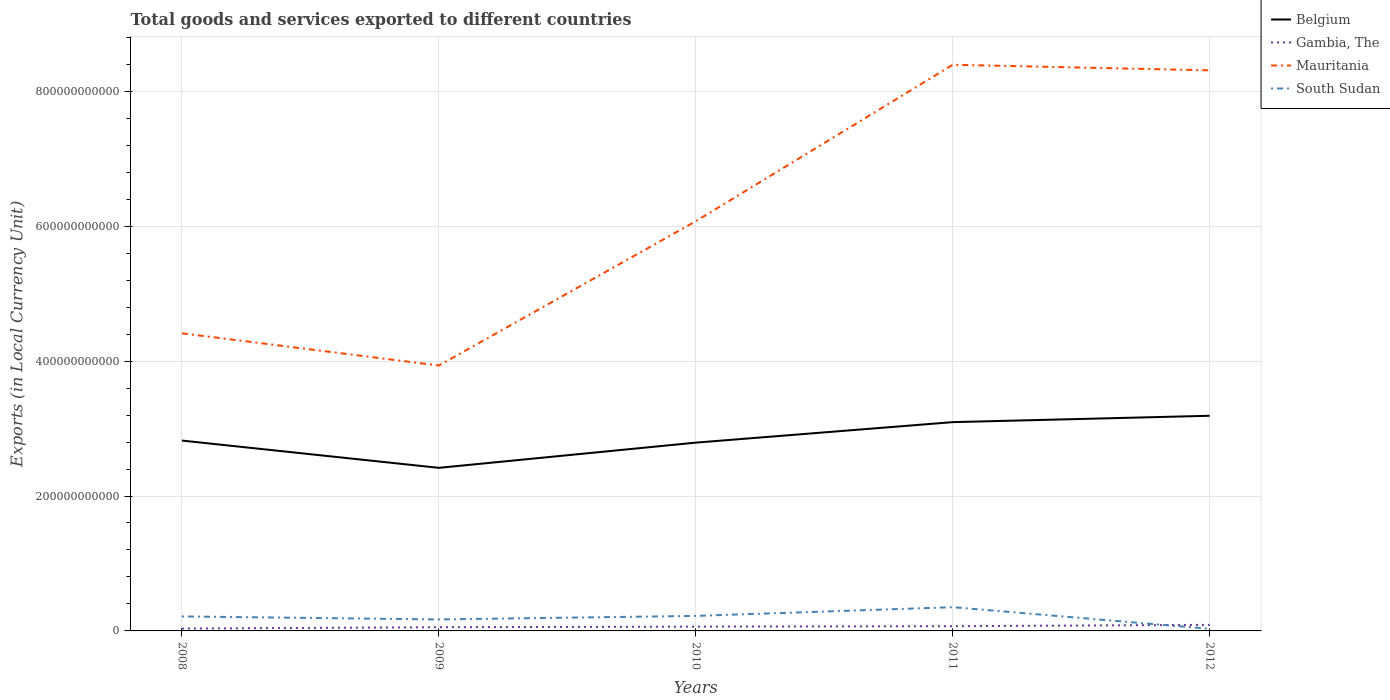How many different coloured lines are there?
Keep it short and to the point. 4. Does the line corresponding to Mauritania intersect with the line corresponding to Belgium?
Provide a short and direct response. No. Is the number of lines equal to the number of legend labels?
Provide a short and direct response. Yes. Across all years, what is the maximum Amount of goods and services exports in Belgium?
Offer a terse response. 2.42e+11. In which year was the Amount of goods and services exports in Belgium maximum?
Your answer should be very brief. 2009. What is the total Amount of goods and services exports in Belgium in the graph?
Your response must be concise. -3.74e+1. What is the difference between the highest and the second highest Amount of goods and services exports in Mauritania?
Provide a succinct answer. 4.46e+11. How many lines are there?
Your answer should be compact. 4. What is the difference between two consecutive major ticks on the Y-axis?
Give a very brief answer. 2.00e+11. Are the values on the major ticks of Y-axis written in scientific E-notation?
Keep it short and to the point. No. How many legend labels are there?
Keep it short and to the point. 4. What is the title of the graph?
Ensure brevity in your answer.  Total goods and services exported to different countries. Does "Solomon Islands" appear as one of the legend labels in the graph?
Keep it short and to the point. No. What is the label or title of the X-axis?
Provide a succinct answer. Years. What is the label or title of the Y-axis?
Your answer should be very brief. Exports (in Local Currency Unit). What is the Exports (in Local Currency Unit) in Belgium in 2008?
Keep it short and to the point. 2.82e+11. What is the Exports (in Local Currency Unit) in Gambia, The in 2008?
Your response must be concise. 3.47e+09. What is the Exports (in Local Currency Unit) in Mauritania in 2008?
Ensure brevity in your answer.  4.41e+11. What is the Exports (in Local Currency Unit) of South Sudan in 2008?
Provide a succinct answer. 2.15e+1. What is the Exports (in Local Currency Unit) in Belgium in 2009?
Your response must be concise. 2.42e+11. What is the Exports (in Local Currency Unit) of Gambia, The in 2009?
Ensure brevity in your answer.  5.50e+09. What is the Exports (in Local Currency Unit) of Mauritania in 2009?
Keep it short and to the point. 3.93e+11. What is the Exports (in Local Currency Unit) in South Sudan in 2009?
Offer a terse response. 1.70e+1. What is the Exports (in Local Currency Unit) of Belgium in 2010?
Provide a short and direct response. 2.79e+11. What is the Exports (in Local Currency Unit) in Gambia, The in 2010?
Your answer should be very brief. 6.34e+09. What is the Exports (in Local Currency Unit) of Mauritania in 2010?
Your response must be concise. 6.07e+11. What is the Exports (in Local Currency Unit) in South Sudan in 2010?
Offer a very short reply. 2.23e+1. What is the Exports (in Local Currency Unit) of Belgium in 2011?
Your response must be concise. 3.09e+11. What is the Exports (in Local Currency Unit) in Gambia, The in 2011?
Make the answer very short. 7.00e+09. What is the Exports (in Local Currency Unit) in Mauritania in 2011?
Give a very brief answer. 8.39e+11. What is the Exports (in Local Currency Unit) in South Sudan in 2011?
Offer a very short reply. 3.52e+1. What is the Exports (in Local Currency Unit) in Belgium in 2012?
Give a very brief answer. 3.19e+11. What is the Exports (in Local Currency Unit) of Gambia, The in 2012?
Offer a very short reply. 9.01e+09. What is the Exports (in Local Currency Unit) of Mauritania in 2012?
Make the answer very short. 8.31e+11. What is the Exports (in Local Currency Unit) in South Sudan in 2012?
Your response must be concise. 3.10e+09. Across all years, what is the maximum Exports (in Local Currency Unit) in Belgium?
Offer a very short reply. 3.19e+11. Across all years, what is the maximum Exports (in Local Currency Unit) in Gambia, The?
Keep it short and to the point. 9.01e+09. Across all years, what is the maximum Exports (in Local Currency Unit) in Mauritania?
Your answer should be compact. 8.39e+11. Across all years, what is the maximum Exports (in Local Currency Unit) in South Sudan?
Offer a terse response. 3.52e+1. Across all years, what is the minimum Exports (in Local Currency Unit) of Belgium?
Your response must be concise. 2.42e+11. Across all years, what is the minimum Exports (in Local Currency Unit) of Gambia, The?
Your response must be concise. 3.47e+09. Across all years, what is the minimum Exports (in Local Currency Unit) of Mauritania?
Offer a terse response. 3.93e+11. Across all years, what is the minimum Exports (in Local Currency Unit) of South Sudan?
Offer a terse response. 3.10e+09. What is the total Exports (in Local Currency Unit) in Belgium in the graph?
Your answer should be compact. 1.43e+12. What is the total Exports (in Local Currency Unit) of Gambia, The in the graph?
Offer a terse response. 3.13e+1. What is the total Exports (in Local Currency Unit) of Mauritania in the graph?
Provide a succinct answer. 3.11e+12. What is the total Exports (in Local Currency Unit) of South Sudan in the graph?
Keep it short and to the point. 9.91e+1. What is the difference between the Exports (in Local Currency Unit) in Belgium in 2008 and that in 2009?
Offer a terse response. 4.04e+1. What is the difference between the Exports (in Local Currency Unit) of Gambia, The in 2008 and that in 2009?
Keep it short and to the point. -2.03e+09. What is the difference between the Exports (in Local Currency Unit) of Mauritania in 2008 and that in 2009?
Give a very brief answer. 4.78e+1. What is the difference between the Exports (in Local Currency Unit) of South Sudan in 2008 and that in 2009?
Give a very brief answer. 4.43e+09. What is the difference between the Exports (in Local Currency Unit) in Belgium in 2008 and that in 2010?
Ensure brevity in your answer.  3.06e+09. What is the difference between the Exports (in Local Currency Unit) of Gambia, The in 2008 and that in 2010?
Give a very brief answer. -2.87e+09. What is the difference between the Exports (in Local Currency Unit) in Mauritania in 2008 and that in 2010?
Make the answer very short. -1.66e+11. What is the difference between the Exports (in Local Currency Unit) of South Sudan in 2008 and that in 2010?
Ensure brevity in your answer.  -7.98e+08. What is the difference between the Exports (in Local Currency Unit) in Belgium in 2008 and that in 2011?
Your response must be concise. -2.73e+1. What is the difference between the Exports (in Local Currency Unit) of Gambia, The in 2008 and that in 2011?
Ensure brevity in your answer.  -3.54e+09. What is the difference between the Exports (in Local Currency Unit) in Mauritania in 2008 and that in 2011?
Provide a short and direct response. -3.98e+11. What is the difference between the Exports (in Local Currency Unit) in South Sudan in 2008 and that in 2011?
Make the answer very short. -1.37e+1. What is the difference between the Exports (in Local Currency Unit) in Belgium in 2008 and that in 2012?
Make the answer very short. -3.68e+1. What is the difference between the Exports (in Local Currency Unit) in Gambia, The in 2008 and that in 2012?
Provide a short and direct response. -5.54e+09. What is the difference between the Exports (in Local Currency Unit) of Mauritania in 2008 and that in 2012?
Ensure brevity in your answer.  -3.90e+11. What is the difference between the Exports (in Local Currency Unit) of South Sudan in 2008 and that in 2012?
Provide a succinct answer. 1.84e+1. What is the difference between the Exports (in Local Currency Unit) in Belgium in 2009 and that in 2010?
Your answer should be compact. -3.74e+1. What is the difference between the Exports (in Local Currency Unit) in Gambia, The in 2009 and that in 2010?
Keep it short and to the point. -8.44e+08. What is the difference between the Exports (in Local Currency Unit) in Mauritania in 2009 and that in 2010?
Give a very brief answer. -2.14e+11. What is the difference between the Exports (in Local Currency Unit) in South Sudan in 2009 and that in 2010?
Provide a succinct answer. -5.23e+09. What is the difference between the Exports (in Local Currency Unit) in Belgium in 2009 and that in 2011?
Ensure brevity in your answer.  -6.77e+1. What is the difference between the Exports (in Local Currency Unit) in Gambia, The in 2009 and that in 2011?
Your answer should be compact. -1.50e+09. What is the difference between the Exports (in Local Currency Unit) of Mauritania in 2009 and that in 2011?
Provide a short and direct response. -4.46e+11. What is the difference between the Exports (in Local Currency Unit) in South Sudan in 2009 and that in 2011?
Keep it short and to the point. -1.82e+1. What is the difference between the Exports (in Local Currency Unit) of Belgium in 2009 and that in 2012?
Offer a very short reply. -7.72e+1. What is the difference between the Exports (in Local Currency Unit) of Gambia, The in 2009 and that in 2012?
Your answer should be very brief. -3.51e+09. What is the difference between the Exports (in Local Currency Unit) of Mauritania in 2009 and that in 2012?
Your response must be concise. -4.38e+11. What is the difference between the Exports (in Local Currency Unit) in South Sudan in 2009 and that in 2012?
Your response must be concise. 1.39e+1. What is the difference between the Exports (in Local Currency Unit) of Belgium in 2010 and that in 2011?
Your answer should be very brief. -3.04e+1. What is the difference between the Exports (in Local Currency Unit) in Gambia, The in 2010 and that in 2011?
Ensure brevity in your answer.  -6.61e+08. What is the difference between the Exports (in Local Currency Unit) in Mauritania in 2010 and that in 2011?
Ensure brevity in your answer.  -2.32e+11. What is the difference between the Exports (in Local Currency Unit) of South Sudan in 2010 and that in 2011?
Provide a succinct answer. -1.29e+1. What is the difference between the Exports (in Local Currency Unit) in Belgium in 2010 and that in 2012?
Your response must be concise. -3.98e+1. What is the difference between the Exports (in Local Currency Unit) in Gambia, The in 2010 and that in 2012?
Offer a very short reply. -2.66e+09. What is the difference between the Exports (in Local Currency Unit) in Mauritania in 2010 and that in 2012?
Your answer should be compact. -2.24e+11. What is the difference between the Exports (in Local Currency Unit) in South Sudan in 2010 and that in 2012?
Offer a very short reply. 1.92e+1. What is the difference between the Exports (in Local Currency Unit) of Belgium in 2011 and that in 2012?
Give a very brief answer. -9.45e+09. What is the difference between the Exports (in Local Currency Unit) of Gambia, The in 2011 and that in 2012?
Provide a short and direct response. -2.00e+09. What is the difference between the Exports (in Local Currency Unit) in Mauritania in 2011 and that in 2012?
Make the answer very short. 8.24e+09. What is the difference between the Exports (in Local Currency Unit) in South Sudan in 2011 and that in 2012?
Your answer should be compact. 3.21e+1. What is the difference between the Exports (in Local Currency Unit) of Belgium in 2008 and the Exports (in Local Currency Unit) of Gambia, The in 2009?
Make the answer very short. 2.77e+11. What is the difference between the Exports (in Local Currency Unit) in Belgium in 2008 and the Exports (in Local Currency Unit) in Mauritania in 2009?
Ensure brevity in your answer.  -1.11e+11. What is the difference between the Exports (in Local Currency Unit) in Belgium in 2008 and the Exports (in Local Currency Unit) in South Sudan in 2009?
Provide a short and direct response. 2.65e+11. What is the difference between the Exports (in Local Currency Unit) of Gambia, The in 2008 and the Exports (in Local Currency Unit) of Mauritania in 2009?
Provide a succinct answer. -3.90e+11. What is the difference between the Exports (in Local Currency Unit) in Gambia, The in 2008 and the Exports (in Local Currency Unit) in South Sudan in 2009?
Offer a very short reply. -1.36e+1. What is the difference between the Exports (in Local Currency Unit) in Mauritania in 2008 and the Exports (in Local Currency Unit) in South Sudan in 2009?
Provide a succinct answer. 4.24e+11. What is the difference between the Exports (in Local Currency Unit) of Belgium in 2008 and the Exports (in Local Currency Unit) of Gambia, The in 2010?
Your response must be concise. 2.76e+11. What is the difference between the Exports (in Local Currency Unit) of Belgium in 2008 and the Exports (in Local Currency Unit) of Mauritania in 2010?
Offer a terse response. -3.25e+11. What is the difference between the Exports (in Local Currency Unit) in Belgium in 2008 and the Exports (in Local Currency Unit) in South Sudan in 2010?
Provide a succinct answer. 2.60e+11. What is the difference between the Exports (in Local Currency Unit) of Gambia, The in 2008 and the Exports (in Local Currency Unit) of Mauritania in 2010?
Your answer should be compact. -6.04e+11. What is the difference between the Exports (in Local Currency Unit) of Gambia, The in 2008 and the Exports (in Local Currency Unit) of South Sudan in 2010?
Your answer should be very brief. -1.88e+1. What is the difference between the Exports (in Local Currency Unit) of Mauritania in 2008 and the Exports (in Local Currency Unit) of South Sudan in 2010?
Keep it short and to the point. 4.19e+11. What is the difference between the Exports (in Local Currency Unit) in Belgium in 2008 and the Exports (in Local Currency Unit) in Gambia, The in 2011?
Offer a terse response. 2.75e+11. What is the difference between the Exports (in Local Currency Unit) of Belgium in 2008 and the Exports (in Local Currency Unit) of Mauritania in 2011?
Your answer should be compact. -5.57e+11. What is the difference between the Exports (in Local Currency Unit) in Belgium in 2008 and the Exports (in Local Currency Unit) in South Sudan in 2011?
Your answer should be compact. 2.47e+11. What is the difference between the Exports (in Local Currency Unit) of Gambia, The in 2008 and the Exports (in Local Currency Unit) of Mauritania in 2011?
Your answer should be very brief. -8.36e+11. What is the difference between the Exports (in Local Currency Unit) of Gambia, The in 2008 and the Exports (in Local Currency Unit) of South Sudan in 2011?
Give a very brief answer. -3.17e+1. What is the difference between the Exports (in Local Currency Unit) in Mauritania in 2008 and the Exports (in Local Currency Unit) in South Sudan in 2011?
Provide a short and direct response. 4.06e+11. What is the difference between the Exports (in Local Currency Unit) in Belgium in 2008 and the Exports (in Local Currency Unit) in Gambia, The in 2012?
Offer a very short reply. 2.73e+11. What is the difference between the Exports (in Local Currency Unit) in Belgium in 2008 and the Exports (in Local Currency Unit) in Mauritania in 2012?
Keep it short and to the point. -5.49e+11. What is the difference between the Exports (in Local Currency Unit) of Belgium in 2008 and the Exports (in Local Currency Unit) of South Sudan in 2012?
Your response must be concise. 2.79e+11. What is the difference between the Exports (in Local Currency Unit) of Gambia, The in 2008 and the Exports (in Local Currency Unit) of Mauritania in 2012?
Your answer should be compact. -8.28e+11. What is the difference between the Exports (in Local Currency Unit) in Gambia, The in 2008 and the Exports (in Local Currency Unit) in South Sudan in 2012?
Provide a short and direct response. 3.71e+08. What is the difference between the Exports (in Local Currency Unit) in Mauritania in 2008 and the Exports (in Local Currency Unit) in South Sudan in 2012?
Your answer should be compact. 4.38e+11. What is the difference between the Exports (in Local Currency Unit) in Belgium in 2009 and the Exports (in Local Currency Unit) in Gambia, The in 2010?
Make the answer very short. 2.35e+11. What is the difference between the Exports (in Local Currency Unit) in Belgium in 2009 and the Exports (in Local Currency Unit) in Mauritania in 2010?
Give a very brief answer. -3.66e+11. What is the difference between the Exports (in Local Currency Unit) in Belgium in 2009 and the Exports (in Local Currency Unit) in South Sudan in 2010?
Ensure brevity in your answer.  2.19e+11. What is the difference between the Exports (in Local Currency Unit) of Gambia, The in 2009 and the Exports (in Local Currency Unit) of Mauritania in 2010?
Give a very brief answer. -6.02e+11. What is the difference between the Exports (in Local Currency Unit) of Gambia, The in 2009 and the Exports (in Local Currency Unit) of South Sudan in 2010?
Ensure brevity in your answer.  -1.68e+1. What is the difference between the Exports (in Local Currency Unit) in Mauritania in 2009 and the Exports (in Local Currency Unit) in South Sudan in 2010?
Provide a succinct answer. 3.71e+11. What is the difference between the Exports (in Local Currency Unit) of Belgium in 2009 and the Exports (in Local Currency Unit) of Gambia, The in 2011?
Your answer should be compact. 2.35e+11. What is the difference between the Exports (in Local Currency Unit) in Belgium in 2009 and the Exports (in Local Currency Unit) in Mauritania in 2011?
Make the answer very short. -5.97e+11. What is the difference between the Exports (in Local Currency Unit) in Belgium in 2009 and the Exports (in Local Currency Unit) in South Sudan in 2011?
Keep it short and to the point. 2.07e+11. What is the difference between the Exports (in Local Currency Unit) in Gambia, The in 2009 and the Exports (in Local Currency Unit) in Mauritania in 2011?
Your response must be concise. -8.34e+11. What is the difference between the Exports (in Local Currency Unit) of Gambia, The in 2009 and the Exports (in Local Currency Unit) of South Sudan in 2011?
Give a very brief answer. -2.97e+1. What is the difference between the Exports (in Local Currency Unit) of Mauritania in 2009 and the Exports (in Local Currency Unit) of South Sudan in 2011?
Make the answer very short. 3.58e+11. What is the difference between the Exports (in Local Currency Unit) in Belgium in 2009 and the Exports (in Local Currency Unit) in Gambia, The in 2012?
Your answer should be compact. 2.33e+11. What is the difference between the Exports (in Local Currency Unit) of Belgium in 2009 and the Exports (in Local Currency Unit) of Mauritania in 2012?
Offer a very short reply. -5.89e+11. What is the difference between the Exports (in Local Currency Unit) in Belgium in 2009 and the Exports (in Local Currency Unit) in South Sudan in 2012?
Provide a short and direct response. 2.39e+11. What is the difference between the Exports (in Local Currency Unit) of Gambia, The in 2009 and the Exports (in Local Currency Unit) of Mauritania in 2012?
Make the answer very short. -8.25e+11. What is the difference between the Exports (in Local Currency Unit) of Gambia, The in 2009 and the Exports (in Local Currency Unit) of South Sudan in 2012?
Your answer should be compact. 2.40e+09. What is the difference between the Exports (in Local Currency Unit) of Mauritania in 2009 and the Exports (in Local Currency Unit) of South Sudan in 2012?
Provide a succinct answer. 3.90e+11. What is the difference between the Exports (in Local Currency Unit) of Belgium in 2010 and the Exports (in Local Currency Unit) of Gambia, The in 2011?
Your answer should be very brief. 2.72e+11. What is the difference between the Exports (in Local Currency Unit) in Belgium in 2010 and the Exports (in Local Currency Unit) in Mauritania in 2011?
Ensure brevity in your answer.  -5.60e+11. What is the difference between the Exports (in Local Currency Unit) in Belgium in 2010 and the Exports (in Local Currency Unit) in South Sudan in 2011?
Provide a short and direct response. 2.44e+11. What is the difference between the Exports (in Local Currency Unit) in Gambia, The in 2010 and the Exports (in Local Currency Unit) in Mauritania in 2011?
Offer a very short reply. -8.33e+11. What is the difference between the Exports (in Local Currency Unit) in Gambia, The in 2010 and the Exports (in Local Currency Unit) in South Sudan in 2011?
Your response must be concise. -2.89e+1. What is the difference between the Exports (in Local Currency Unit) in Mauritania in 2010 and the Exports (in Local Currency Unit) in South Sudan in 2011?
Give a very brief answer. 5.72e+11. What is the difference between the Exports (in Local Currency Unit) of Belgium in 2010 and the Exports (in Local Currency Unit) of Gambia, The in 2012?
Offer a terse response. 2.70e+11. What is the difference between the Exports (in Local Currency Unit) in Belgium in 2010 and the Exports (in Local Currency Unit) in Mauritania in 2012?
Give a very brief answer. -5.52e+11. What is the difference between the Exports (in Local Currency Unit) in Belgium in 2010 and the Exports (in Local Currency Unit) in South Sudan in 2012?
Provide a succinct answer. 2.76e+11. What is the difference between the Exports (in Local Currency Unit) of Gambia, The in 2010 and the Exports (in Local Currency Unit) of Mauritania in 2012?
Offer a terse response. -8.25e+11. What is the difference between the Exports (in Local Currency Unit) in Gambia, The in 2010 and the Exports (in Local Currency Unit) in South Sudan in 2012?
Offer a very short reply. 3.24e+09. What is the difference between the Exports (in Local Currency Unit) of Mauritania in 2010 and the Exports (in Local Currency Unit) of South Sudan in 2012?
Give a very brief answer. 6.04e+11. What is the difference between the Exports (in Local Currency Unit) of Belgium in 2011 and the Exports (in Local Currency Unit) of Gambia, The in 2012?
Your answer should be very brief. 3.00e+11. What is the difference between the Exports (in Local Currency Unit) in Belgium in 2011 and the Exports (in Local Currency Unit) in Mauritania in 2012?
Ensure brevity in your answer.  -5.22e+11. What is the difference between the Exports (in Local Currency Unit) of Belgium in 2011 and the Exports (in Local Currency Unit) of South Sudan in 2012?
Your answer should be very brief. 3.06e+11. What is the difference between the Exports (in Local Currency Unit) in Gambia, The in 2011 and the Exports (in Local Currency Unit) in Mauritania in 2012?
Offer a very short reply. -8.24e+11. What is the difference between the Exports (in Local Currency Unit) in Gambia, The in 2011 and the Exports (in Local Currency Unit) in South Sudan in 2012?
Give a very brief answer. 3.91e+09. What is the difference between the Exports (in Local Currency Unit) in Mauritania in 2011 and the Exports (in Local Currency Unit) in South Sudan in 2012?
Give a very brief answer. 8.36e+11. What is the average Exports (in Local Currency Unit) in Belgium per year?
Provide a succinct answer. 2.86e+11. What is the average Exports (in Local Currency Unit) of Gambia, The per year?
Your answer should be very brief. 6.26e+09. What is the average Exports (in Local Currency Unit) in Mauritania per year?
Provide a short and direct response. 6.22e+11. What is the average Exports (in Local Currency Unit) of South Sudan per year?
Provide a succinct answer. 1.98e+1. In the year 2008, what is the difference between the Exports (in Local Currency Unit) of Belgium and Exports (in Local Currency Unit) of Gambia, The?
Your response must be concise. 2.79e+11. In the year 2008, what is the difference between the Exports (in Local Currency Unit) of Belgium and Exports (in Local Currency Unit) of Mauritania?
Make the answer very short. -1.59e+11. In the year 2008, what is the difference between the Exports (in Local Currency Unit) in Belgium and Exports (in Local Currency Unit) in South Sudan?
Your answer should be very brief. 2.61e+11. In the year 2008, what is the difference between the Exports (in Local Currency Unit) of Gambia, The and Exports (in Local Currency Unit) of Mauritania?
Your answer should be compact. -4.38e+11. In the year 2008, what is the difference between the Exports (in Local Currency Unit) of Gambia, The and Exports (in Local Currency Unit) of South Sudan?
Your response must be concise. -1.80e+1. In the year 2008, what is the difference between the Exports (in Local Currency Unit) in Mauritania and Exports (in Local Currency Unit) in South Sudan?
Offer a terse response. 4.20e+11. In the year 2009, what is the difference between the Exports (in Local Currency Unit) in Belgium and Exports (in Local Currency Unit) in Gambia, The?
Your response must be concise. 2.36e+11. In the year 2009, what is the difference between the Exports (in Local Currency Unit) of Belgium and Exports (in Local Currency Unit) of Mauritania?
Provide a short and direct response. -1.52e+11. In the year 2009, what is the difference between the Exports (in Local Currency Unit) of Belgium and Exports (in Local Currency Unit) of South Sudan?
Give a very brief answer. 2.25e+11. In the year 2009, what is the difference between the Exports (in Local Currency Unit) in Gambia, The and Exports (in Local Currency Unit) in Mauritania?
Offer a terse response. -3.88e+11. In the year 2009, what is the difference between the Exports (in Local Currency Unit) in Gambia, The and Exports (in Local Currency Unit) in South Sudan?
Your response must be concise. -1.15e+1. In the year 2009, what is the difference between the Exports (in Local Currency Unit) of Mauritania and Exports (in Local Currency Unit) of South Sudan?
Give a very brief answer. 3.76e+11. In the year 2010, what is the difference between the Exports (in Local Currency Unit) of Belgium and Exports (in Local Currency Unit) of Gambia, The?
Offer a terse response. 2.73e+11. In the year 2010, what is the difference between the Exports (in Local Currency Unit) of Belgium and Exports (in Local Currency Unit) of Mauritania?
Offer a terse response. -3.28e+11. In the year 2010, what is the difference between the Exports (in Local Currency Unit) of Belgium and Exports (in Local Currency Unit) of South Sudan?
Ensure brevity in your answer.  2.57e+11. In the year 2010, what is the difference between the Exports (in Local Currency Unit) in Gambia, The and Exports (in Local Currency Unit) in Mauritania?
Keep it short and to the point. -6.01e+11. In the year 2010, what is the difference between the Exports (in Local Currency Unit) of Gambia, The and Exports (in Local Currency Unit) of South Sudan?
Offer a terse response. -1.59e+1. In the year 2010, what is the difference between the Exports (in Local Currency Unit) of Mauritania and Exports (in Local Currency Unit) of South Sudan?
Offer a terse response. 5.85e+11. In the year 2011, what is the difference between the Exports (in Local Currency Unit) of Belgium and Exports (in Local Currency Unit) of Gambia, The?
Provide a short and direct response. 3.02e+11. In the year 2011, what is the difference between the Exports (in Local Currency Unit) of Belgium and Exports (in Local Currency Unit) of Mauritania?
Provide a short and direct response. -5.30e+11. In the year 2011, what is the difference between the Exports (in Local Currency Unit) in Belgium and Exports (in Local Currency Unit) in South Sudan?
Provide a succinct answer. 2.74e+11. In the year 2011, what is the difference between the Exports (in Local Currency Unit) of Gambia, The and Exports (in Local Currency Unit) of Mauritania?
Your response must be concise. -8.32e+11. In the year 2011, what is the difference between the Exports (in Local Currency Unit) of Gambia, The and Exports (in Local Currency Unit) of South Sudan?
Make the answer very short. -2.82e+1. In the year 2011, what is the difference between the Exports (in Local Currency Unit) in Mauritania and Exports (in Local Currency Unit) in South Sudan?
Your answer should be compact. 8.04e+11. In the year 2012, what is the difference between the Exports (in Local Currency Unit) in Belgium and Exports (in Local Currency Unit) in Gambia, The?
Provide a succinct answer. 3.10e+11. In the year 2012, what is the difference between the Exports (in Local Currency Unit) of Belgium and Exports (in Local Currency Unit) of Mauritania?
Offer a terse response. -5.12e+11. In the year 2012, what is the difference between the Exports (in Local Currency Unit) in Belgium and Exports (in Local Currency Unit) in South Sudan?
Provide a short and direct response. 3.16e+11. In the year 2012, what is the difference between the Exports (in Local Currency Unit) in Gambia, The and Exports (in Local Currency Unit) in Mauritania?
Ensure brevity in your answer.  -8.22e+11. In the year 2012, what is the difference between the Exports (in Local Currency Unit) of Gambia, The and Exports (in Local Currency Unit) of South Sudan?
Provide a short and direct response. 5.91e+09. In the year 2012, what is the difference between the Exports (in Local Currency Unit) in Mauritania and Exports (in Local Currency Unit) in South Sudan?
Your answer should be compact. 8.28e+11. What is the ratio of the Exports (in Local Currency Unit) of Belgium in 2008 to that in 2009?
Provide a short and direct response. 1.17. What is the ratio of the Exports (in Local Currency Unit) in Gambia, The in 2008 to that in 2009?
Give a very brief answer. 0.63. What is the ratio of the Exports (in Local Currency Unit) of Mauritania in 2008 to that in 2009?
Offer a very short reply. 1.12. What is the ratio of the Exports (in Local Currency Unit) in South Sudan in 2008 to that in 2009?
Offer a terse response. 1.26. What is the ratio of the Exports (in Local Currency Unit) of Gambia, The in 2008 to that in 2010?
Make the answer very short. 0.55. What is the ratio of the Exports (in Local Currency Unit) of Mauritania in 2008 to that in 2010?
Your response must be concise. 0.73. What is the ratio of the Exports (in Local Currency Unit) of South Sudan in 2008 to that in 2010?
Your answer should be very brief. 0.96. What is the ratio of the Exports (in Local Currency Unit) in Belgium in 2008 to that in 2011?
Provide a short and direct response. 0.91. What is the ratio of the Exports (in Local Currency Unit) of Gambia, The in 2008 to that in 2011?
Ensure brevity in your answer.  0.5. What is the ratio of the Exports (in Local Currency Unit) of Mauritania in 2008 to that in 2011?
Offer a very short reply. 0.53. What is the ratio of the Exports (in Local Currency Unit) in South Sudan in 2008 to that in 2011?
Your answer should be compact. 0.61. What is the ratio of the Exports (in Local Currency Unit) of Belgium in 2008 to that in 2012?
Your response must be concise. 0.88. What is the ratio of the Exports (in Local Currency Unit) in Gambia, The in 2008 to that in 2012?
Provide a short and direct response. 0.38. What is the ratio of the Exports (in Local Currency Unit) of Mauritania in 2008 to that in 2012?
Provide a succinct answer. 0.53. What is the ratio of the Exports (in Local Currency Unit) in South Sudan in 2008 to that in 2012?
Provide a short and direct response. 6.94. What is the ratio of the Exports (in Local Currency Unit) of Belgium in 2009 to that in 2010?
Your answer should be very brief. 0.87. What is the ratio of the Exports (in Local Currency Unit) in Gambia, The in 2009 to that in 2010?
Your answer should be very brief. 0.87. What is the ratio of the Exports (in Local Currency Unit) in Mauritania in 2009 to that in 2010?
Your answer should be compact. 0.65. What is the ratio of the Exports (in Local Currency Unit) of South Sudan in 2009 to that in 2010?
Keep it short and to the point. 0.77. What is the ratio of the Exports (in Local Currency Unit) in Belgium in 2009 to that in 2011?
Your response must be concise. 0.78. What is the ratio of the Exports (in Local Currency Unit) in Gambia, The in 2009 to that in 2011?
Make the answer very short. 0.79. What is the ratio of the Exports (in Local Currency Unit) in Mauritania in 2009 to that in 2011?
Offer a terse response. 0.47. What is the ratio of the Exports (in Local Currency Unit) in South Sudan in 2009 to that in 2011?
Provide a succinct answer. 0.48. What is the ratio of the Exports (in Local Currency Unit) of Belgium in 2009 to that in 2012?
Your answer should be very brief. 0.76. What is the ratio of the Exports (in Local Currency Unit) of Gambia, The in 2009 to that in 2012?
Keep it short and to the point. 0.61. What is the ratio of the Exports (in Local Currency Unit) in Mauritania in 2009 to that in 2012?
Provide a short and direct response. 0.47. What is the ratio of the Exports (in Local Currency Unit) in South Sudan in 2009 to that in 2012?
Your answer should be very brief. 5.5. What is the ratio of the Exports (in Local Currency Unit) in Belgium in 2010 to that in 2011?
Offer a very short reply. 0.9. What is the ratio of the Exports (in Local Currency Unit) in Gambia, The in 2010 to that in 2011?
Your answer should be compact. 0.91. What is the ratio of the Exports (in Local Currency Unit) in Mauritania in 2010 to that in 2011?
Your answer should be compact. 0.72. What is the ratio of the Exports (in Local Currency Unit) of South Sudan in 2010 to that in 2011?
Provide a short and direct response. 0.63. What is the ratio of the Exports (in Local Currency Unit) of Belgium in 2010 to that in 2012?
Offer a terse response. 0.88. What is the ratio of the Exports (in Local Currency Unit) in Gambia, The in 2010 to that in 2012?
Make the answer very short. 0.7. What is the ratio of the Exports (in Local Currency Unit) of Mauritania in 2010 to that in 2012?
Provide a succinct answer. 0.73. What is the ratio of the Exports (in Local Currency Unit) in South Sudan in 2010 to that in 2012?
Give a very brief answer. 7.19. What is the ratio of the Exports (in Local Currency Unit) in Belgium in 2011 to that in 2012?
Provide a short and direct response. 0.97. What is the ratio of the Exports (in Local Currency Unit) in Gambia, The in 2011 to that in 2012?
Your answer should be very brief. 0.78. What is the ratio of the Exports (in Local Currency Unit) in Mauritania in 2011 to that in 2012?
Your answer should be very brief. 1.01. What is the ratio of the Exports (in Local Currency Unit) in South Sudan in 2011 to that in 2012?
Make the answer very short. 11.37. What is the difference between the highest and the second highest Exports (in Local Currency Unit) of Belgium?
Provide a short and direct response. 9.45e+09. What is the difference between the highest and the second highest Exports (in Local Currency Unit) of Gambia, The?
Give a very brief answer. 2.00e+09. What is the difference between the highest and the second highest Exports (in Local Currency Unit) in Mauritania?
Keep it short and to the point. 8.24e+09. What is the difference between the highest and the second highest Exports (in Local Currency Unit) in South Sudan?
Offer a terse response. 1.29e+1. What is the difference between the highest and the lowest Exports (in Local Currency Unit) of Belgium?
Ensure brevity in your answer.  7.72e+1. What is the difference between the highest and the lowest Exports (in Local Currency Unit) in Gambia, The?
Ensure brevity in your answer.  5.54e+09. What is the difference between the highest and the lowest Exports (in Local Currency Unit) of Mauritania?
Provide a short and direct response. 4.46e+11. What is the difference between the highest and the lowest Exports (in Local Currency Unit) in South Sudan?
Give a very brief answer. 3.21e+1. 